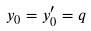Convert formula to latex. <formula><loc_0><loc_0><loc_500><loc_500>y _ { 0 } = y _ { 0 } ^ { \prime } = q</formula> 